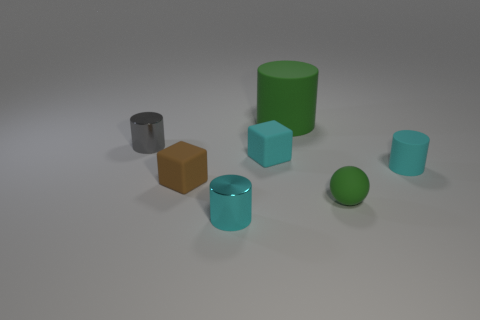Is there anything else that has the same size as the green cylinder?
Offer a terse response. No. How many tiny green balls have the same material as the large green cylinder?
Your answer should be very brief. 1. There is a thing that is on the right side of the small rubber sphere; how many cyan cubes are right of it?
Your answer should be compact. 0. Is the color of the small cube to the left of the cyan matte block the same as the small cylinder right of the tiny matte sphere?
Keep it short and to the point. No. There is a object that is behind the tiny rubber cylinder and in front of the small gray thing; what shape is it?
Provide a short and direct response. Cube. Is there a cyan metallic thing that has the same shape as the tiny gray object?
Your answer should be compact. Yes. There is a brown object that is the same size as the gray metallic object; what is its shape?
Your answer should be compact. Cube. What is the big green object made of?
Ensure brevity in your answer.  Rubber. There is a green rubber object left of the small ball that is to the right of the tiny cyan cylinder that is left of the big green rubber cylinder; what is its size?
Give a very brief answer. Large. There is a object that is the same color as the large cylinder; what is its material?
Ensure brevity in your answer.  Rubber. 